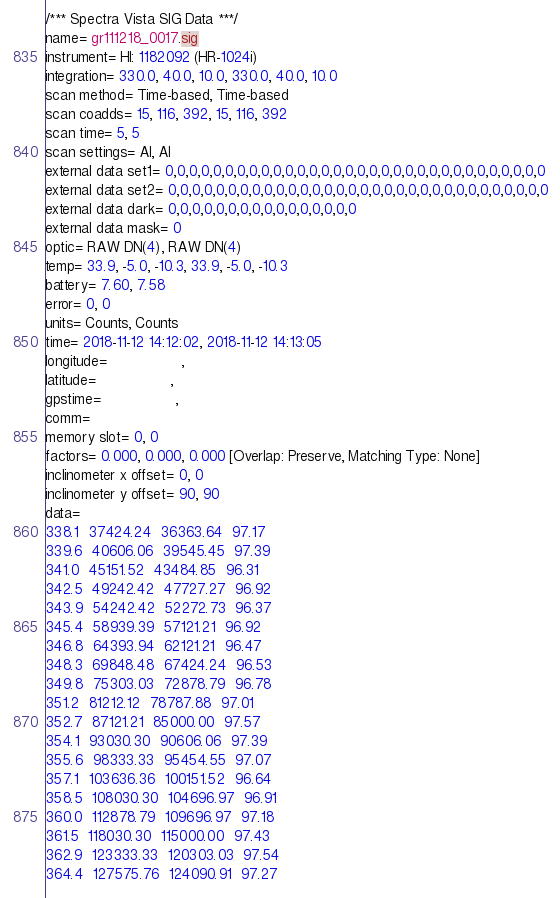Convert code to text. <code><loc_0><loc_0><loc_500><loc_500><_SML_>/*** Spectra Vista SIG Data ***/
name= gr111218_0017.sig
instrument= HI: 1182092 (HR-1024i)
integration= 330.0, 40.0, 10.0, 330.0, 40.0, 10.0
scan method= Time-based, Time-based
scan coadds= 15, 116, 392, 15, 116, 392
scan time= 5, 5
scan settings= AI, AI
external data set1= 0,0,0,0,0,0,0,0,0,0,0,0,0,0,0,0,0,0,0,0,0,0,0,0,0,0,0,0,0,0,0,0
external data set2= 0,0,0,0,0,0,0,0,0,0,0,0,0,0,0,0,0,0,0,0,0,0,0,0,0,0,0,0,0,0,0,0
external data dark= 0,0,0,0,0,0,0,0,0,0,0,0,0,0,0,0
external data mask= 0
optic= RAW DN(4), RAW DN(4)
temp= 33.9, -5.0, -10.3, 33.9, -5.0, -10.3
battery= 7.60, 7.58
error= 0, 0
units= Counts, Counts
time= 2018-11-12 14:12:02, 2018-11-12 14:13:05
longitude=                 ,                 
latitude=                 ,                 
gpstime=                 ,                 
comm= 
memory slot= 0, 0
factors= 0.000, 0.000, 0.000 [Overlap: Preserve, Matching Type: None]
inclinometer x offset= 0, 0
inclinometer y offset= 90, 90
data= 
338.1  37424.24  36363.64  97.17
339.6  40606.06  39545.45  97.39
341.0  45151.52  43484.85  96.31
342.5  49242.42  47727.27  96.92
343.9  54242.42  52272.73  96.37
345.4  58939.39  57121.21  96.92
346.8  64393.94  62121.21  96.47
348.3  69848.48  67424.24  96.53
349.8  75303.03  72878.79  96.78
351.2  81212.12  78787.88  97.01
352.7  87121.21  85000.00  97.57
354.1  93030.30  90606.06  97.39
355.6  98333.33  95454.55  97.07
357.1  103636.36  100151.52  96.64
358.5  108030.30  104696.97  96.91
360.0  112878.79  109696.97  97.18
361.5  118030.30  115000.00  97.43
362.9  123333.33  120303.03  97.54
364.4  127575.76  124090.91  97.27</code> 